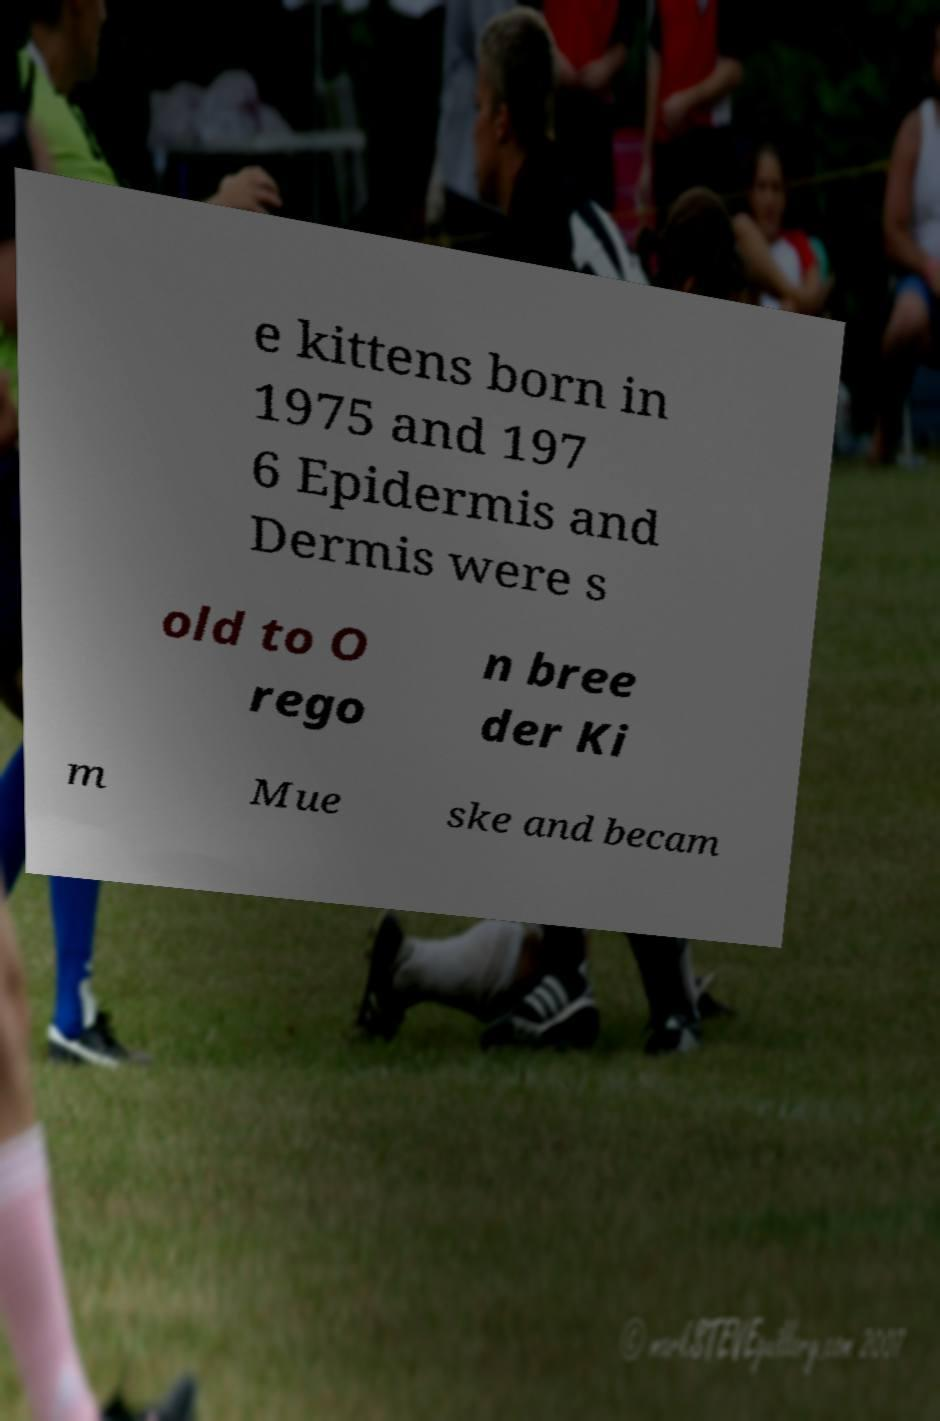I need the written content from this picture converted into text. Can you do that? e kittens born in 1975 and 197 6 Epidermis and Dermis were s old to O rego n bree der Ki m Mue ske and becam 